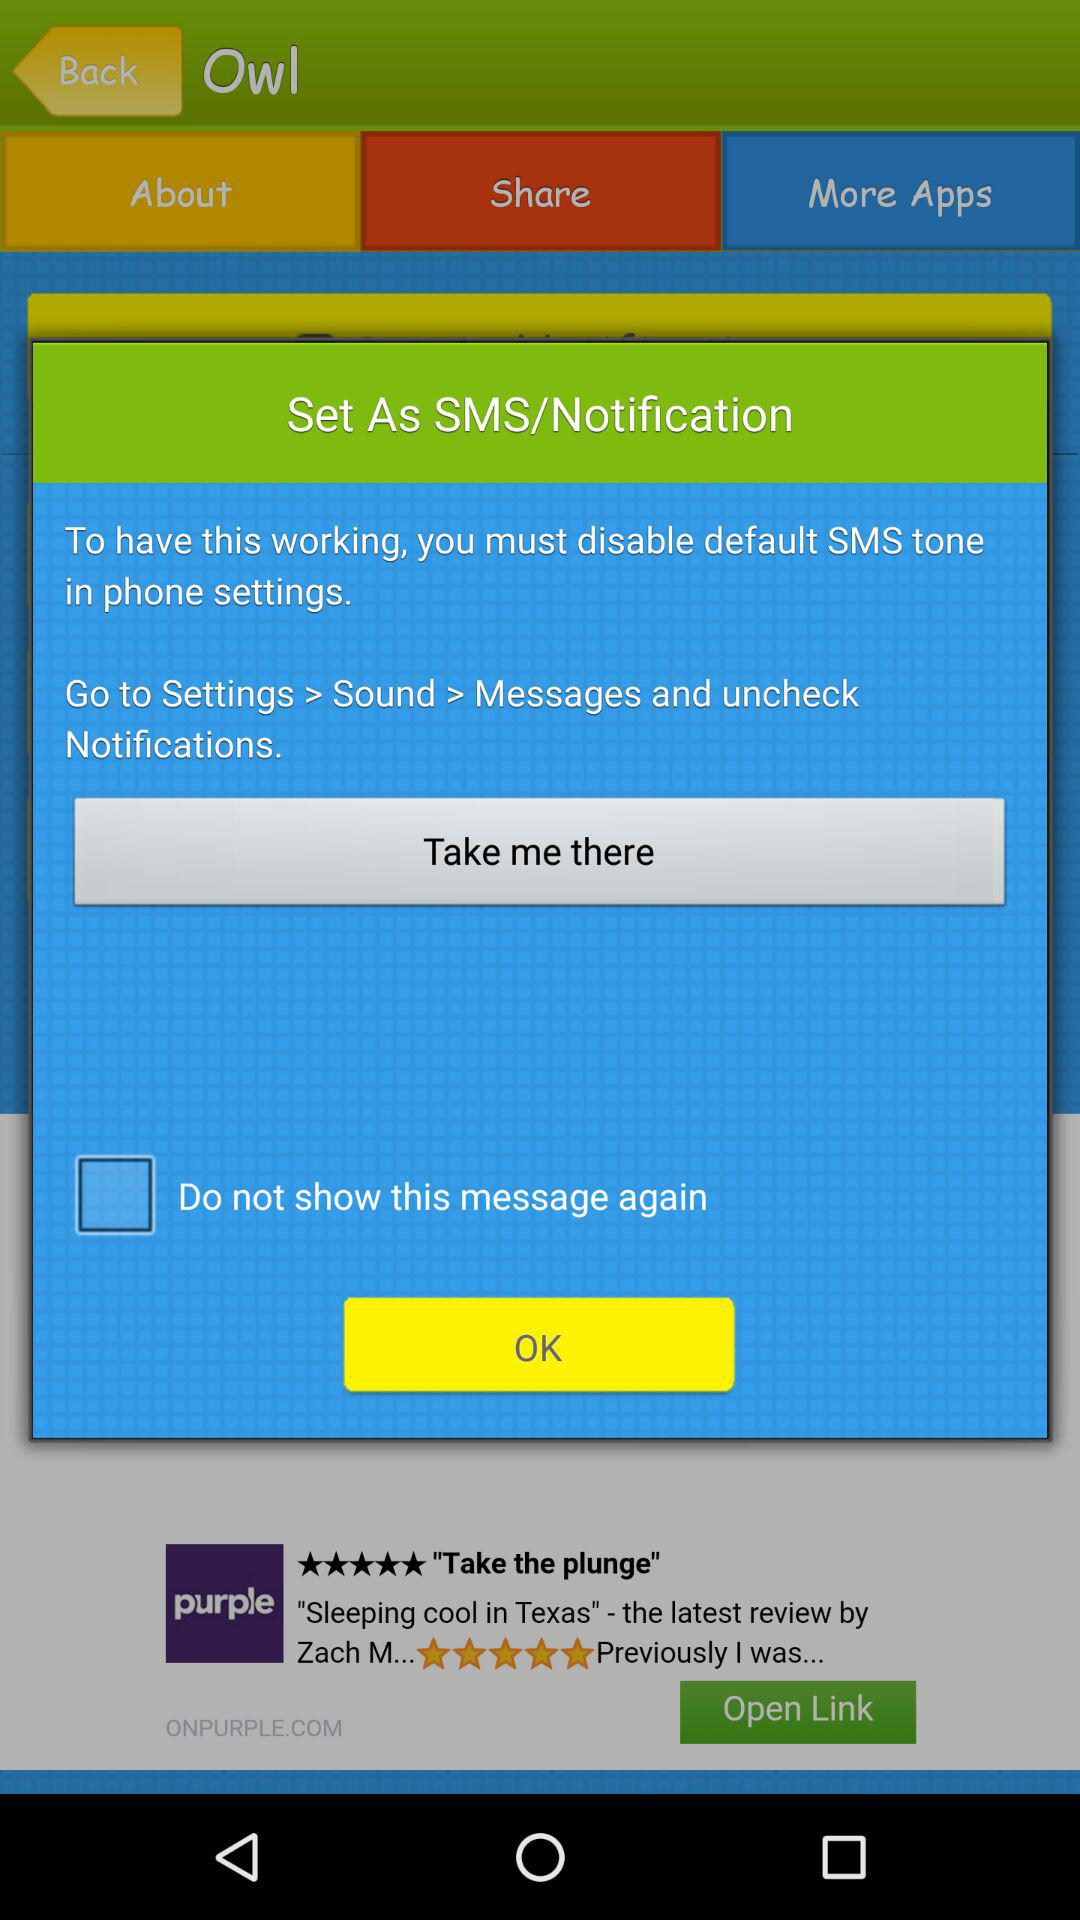What's the status of "Do not show this message again"? The status of "Do not show this message again" is "off". 